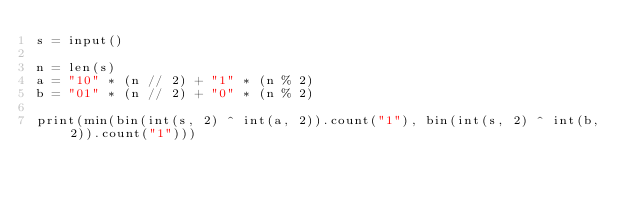<code> <loc_0><loc_0><loc_500><loc_500><_Python_>s = input()

n = len(s)
a = "10" * (n // 2) + "1" * (n % 2)
b = "01" * (n // 2) + "0" * (n % 2)

print(min(bin(int(s, 2) ^ int(a, 2)).count("1"), bin(int(s, 2) ^ int(b, 2)).count("1")))
</code> 